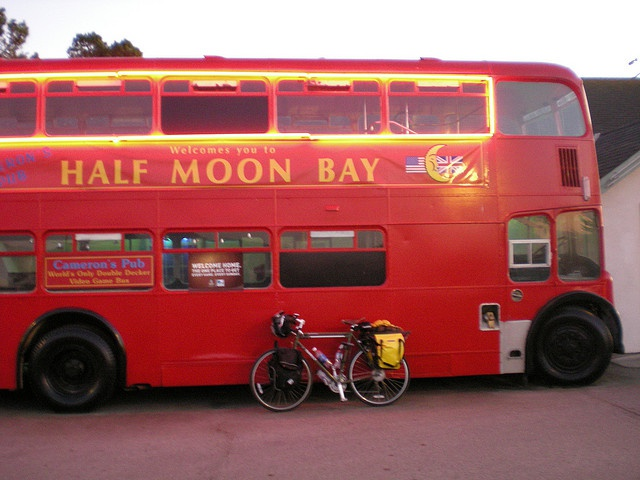Describe the objects in this image and their specific colors. I can see bus in lavender, brown, black, and salmon tones, bicycle in lavender, black, maroon, and gray tones, backpack in lavender, black, maroon, and gray tones, bottle in lavender, brown, purple, and gray tones, and bottle in lavender, purple, brown, maroon, and gray tones in this image. 